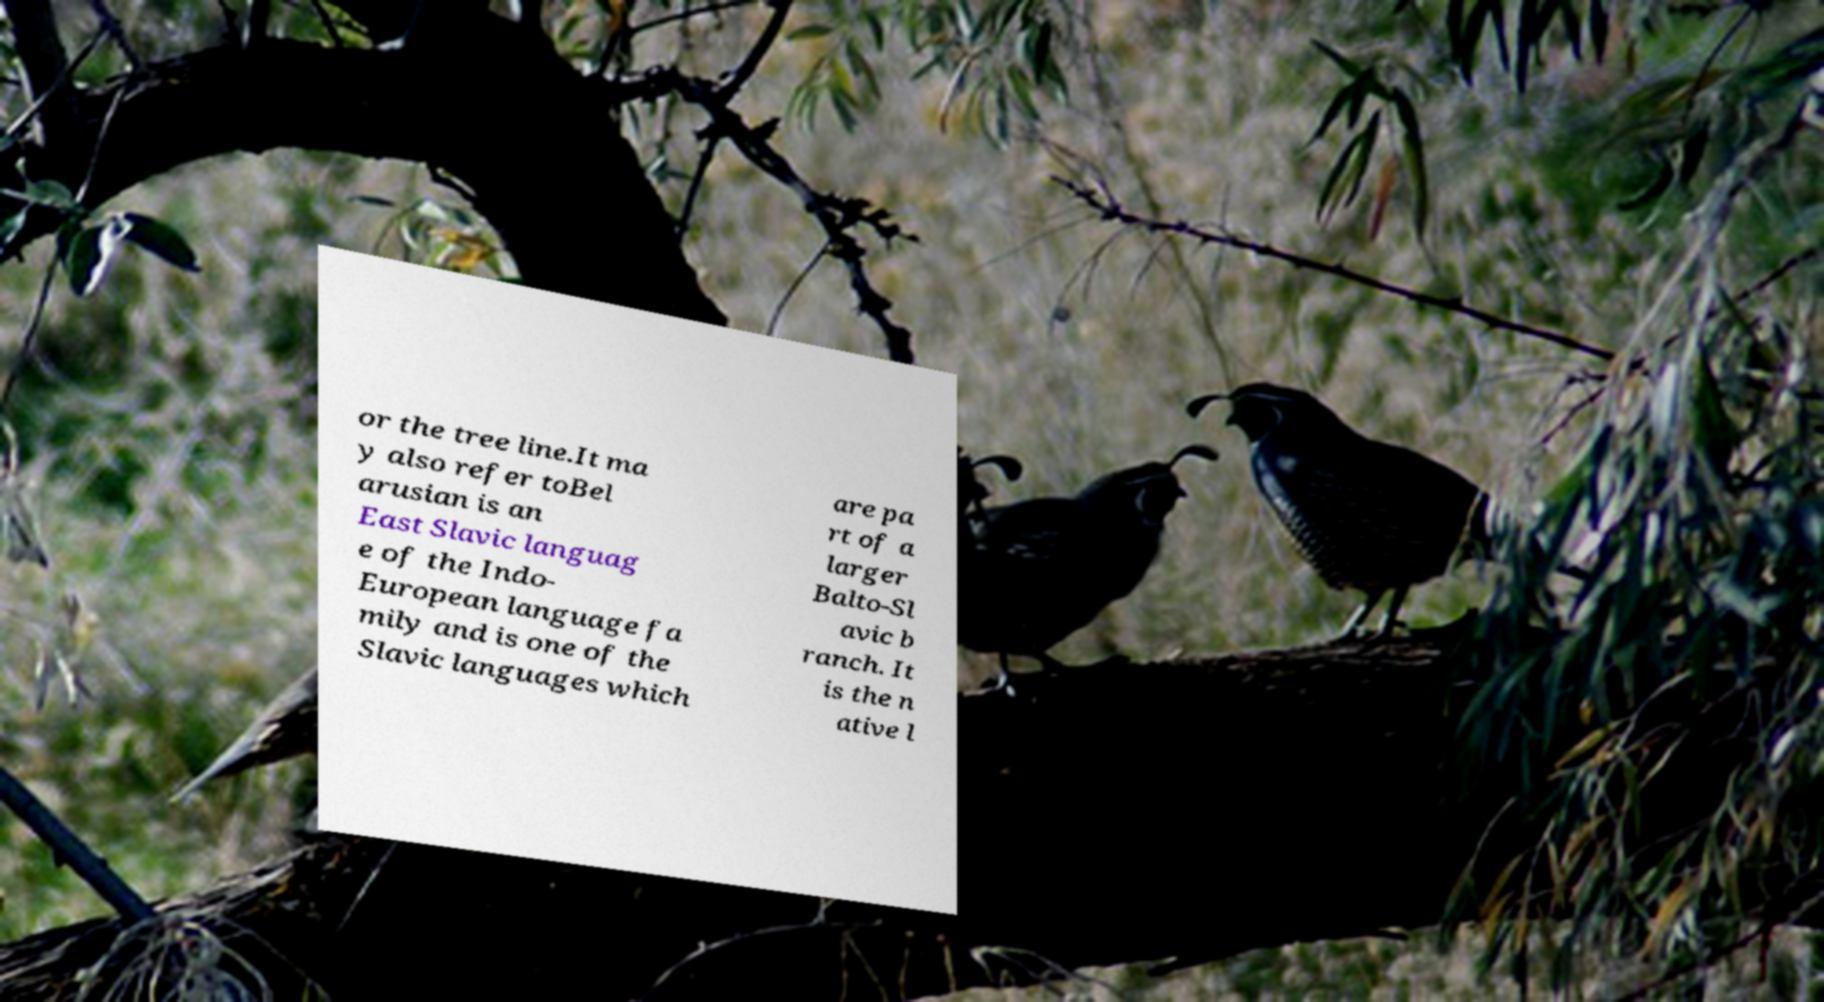Could you assist in decoding the text presented in this image and type it out clearly? or the tree line.It ma y also refer toBel arusian is an East Slavic languag e of the Indo- European language fa mily and is one of the Slavic languages which are pa rt of a larger Balto-Sl avic b ranch. It is the n ative l 